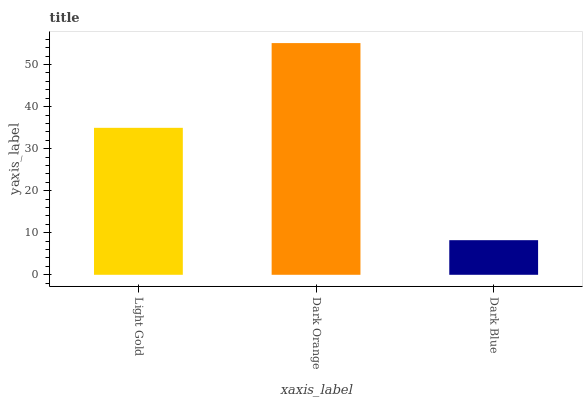Is Dark Blue the minimum?
Answer yes or no. Yes. Is Dark Orange the maximum?
Answer yes or no. Yes. Is Dark Orange the minimum?
Answer yes or no. No. Is Dark Blue the maximum?
Answer yes or no. No. Is Dark Orange greater than Dark Blue?
Answer yes or no. Yes. Is Dark Blue less than Dark Orange?
Answer yes or no. Yes. Is Dark Blue greater than Dark Orange?
Answer yes or no. No. Is Dark Orange less than Dark Blue?
Answer yes or no. No. Is Light Gold the high median?
Answer yes or no. Yes. Is Light Gold the low median?
Answer yes or no. Yes. Is Dark Orange the high median?
Answer yes or no. No. Is Dark Orange the low median?
Answer yes or no. No. 